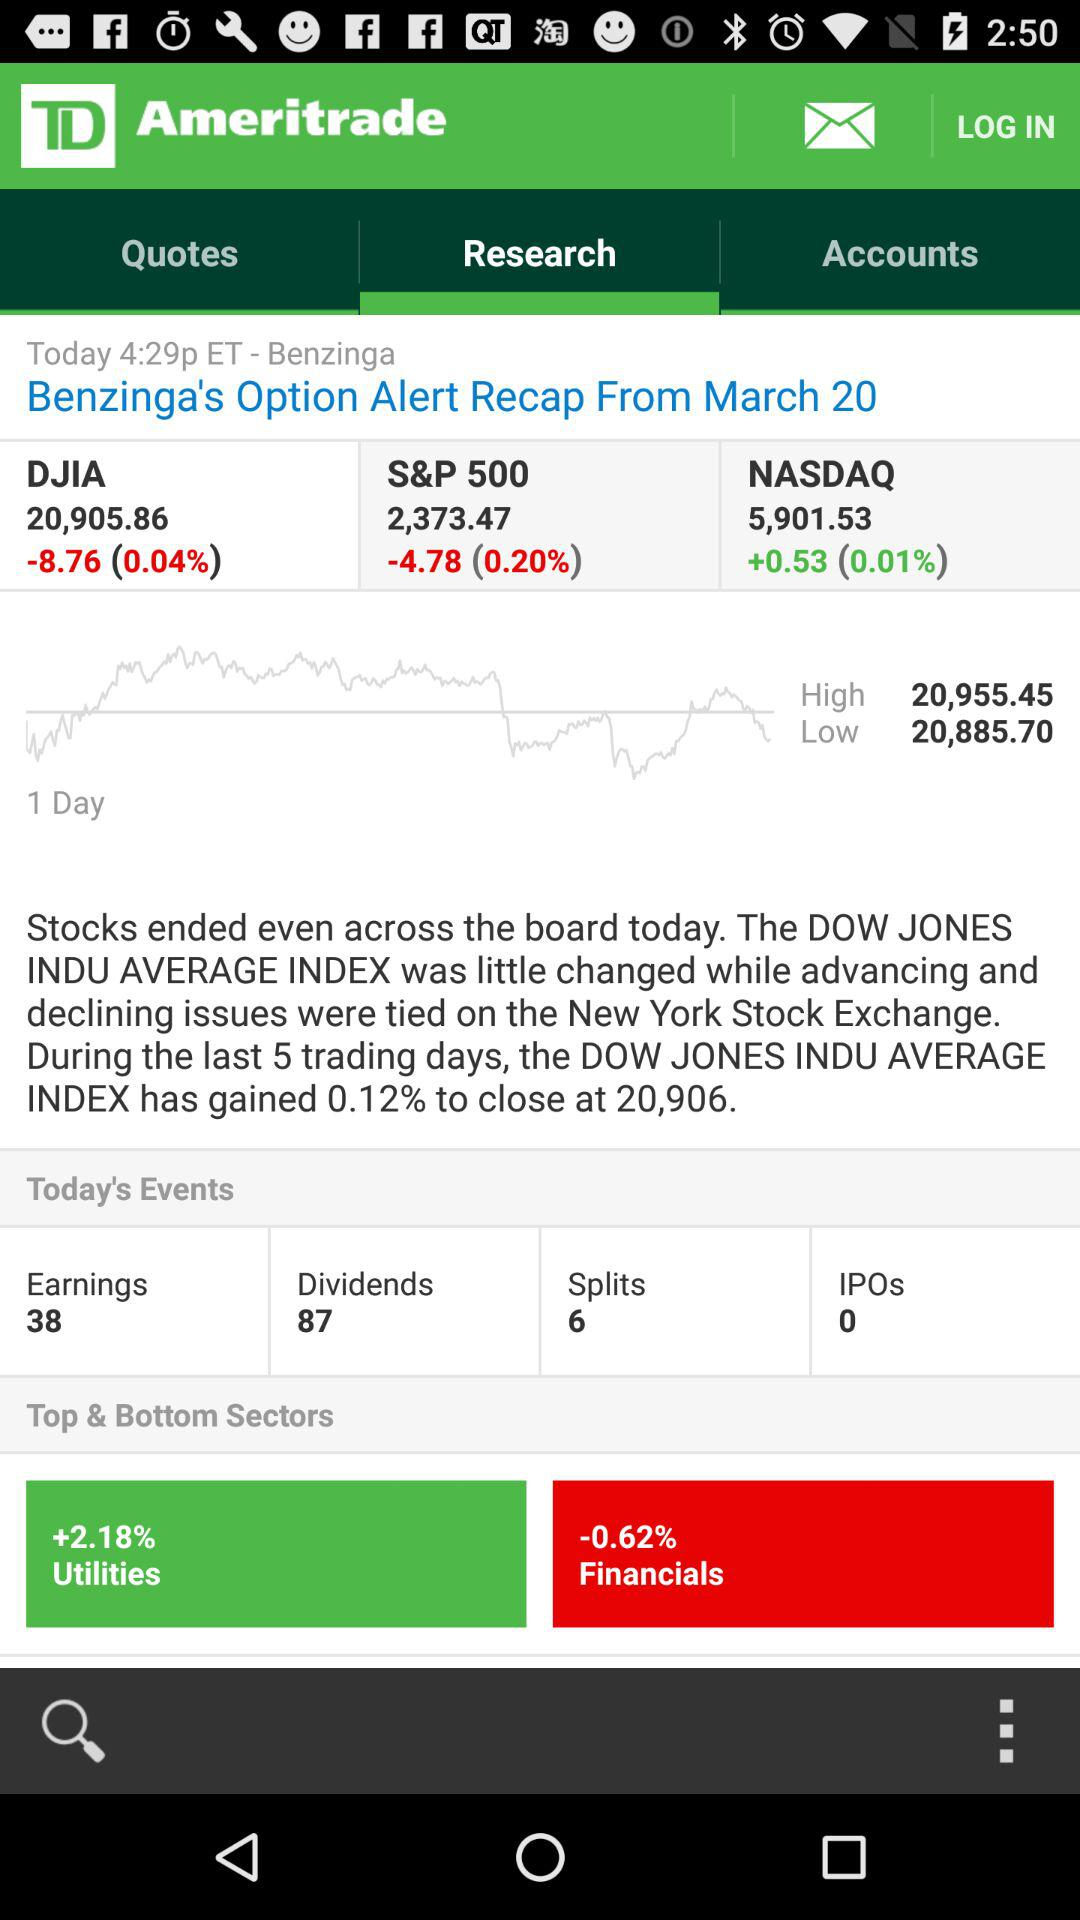Which sector has the highest percentage gain? As shown in the image, the Utilities sector has the highest percentage gain, up by 2.18%. 